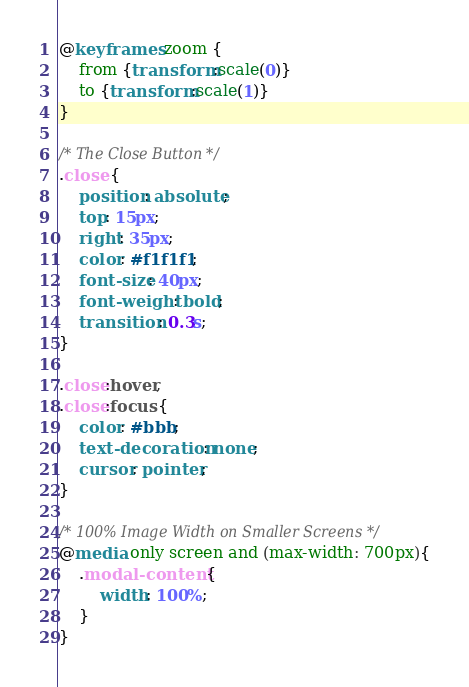Convert code to text. <code><loc_0><loc_0><loc_500><loc_500><_CSS_>@keyframes zoom {
    from {transform:scale(0)} 
    to {transform:scale(1)}
}

/* The Close Button */
.close {
    position: absolute;
    top: 15px;
    right: 35px;
    color: #f1f1f1;
    font-size: 40px;
    font-weight: bold;
    transition: 0.3s;
}

.close:hover,
.close:focus {
    color: #bbb;
    text-decoration: none;
    cursor: pointer;
}

/* 100% Image Width on Smaller Screens */
@media only screen and (max-width: 700px){
    .modal-content {
        width: 100%;
    }
}
</code> 